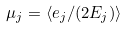<formula> <loc_0><loc_0><loc_500><loc_500>\mu _ { j } = \left < e _ { j } / ( 2 E _ { j } ) \right ></formula> 